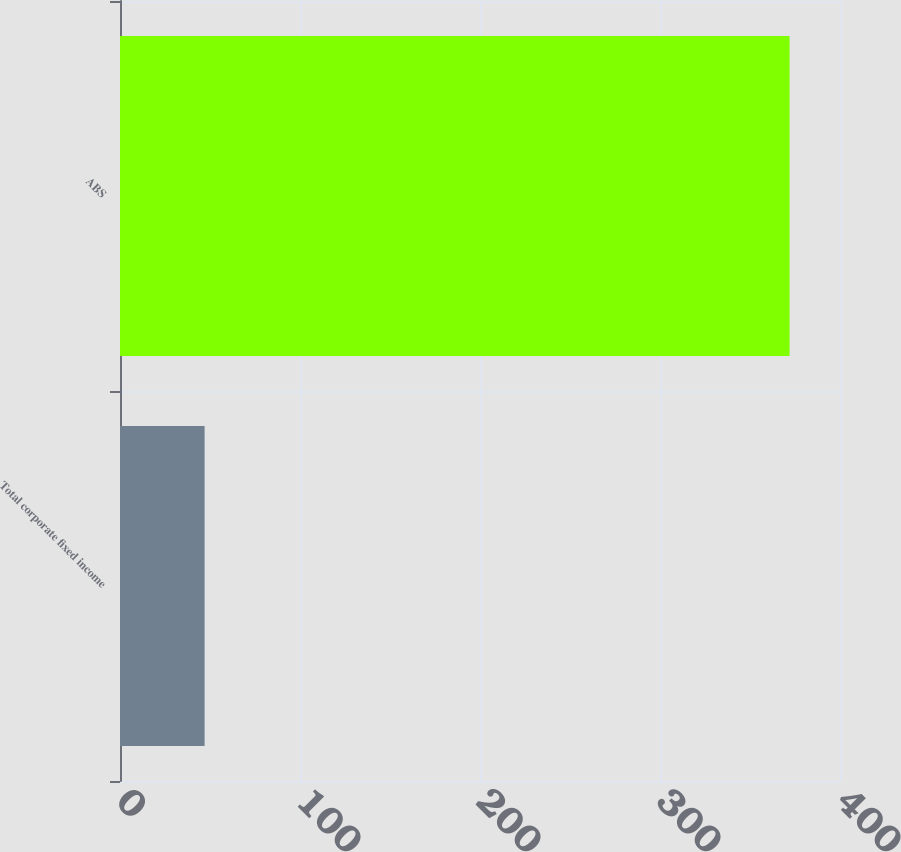<chart> <loc_0><loc_0><loc_500><loc_500><bar_chart><fcel>Total corporate fixed income<fcel>ABS<nl><fcel>47<fcel>372<nl></chart> 